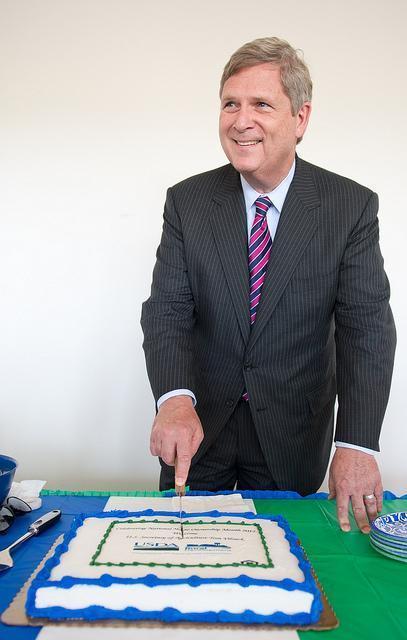How many beverage bottles are in the background?
Give a very brief answer. 0. 